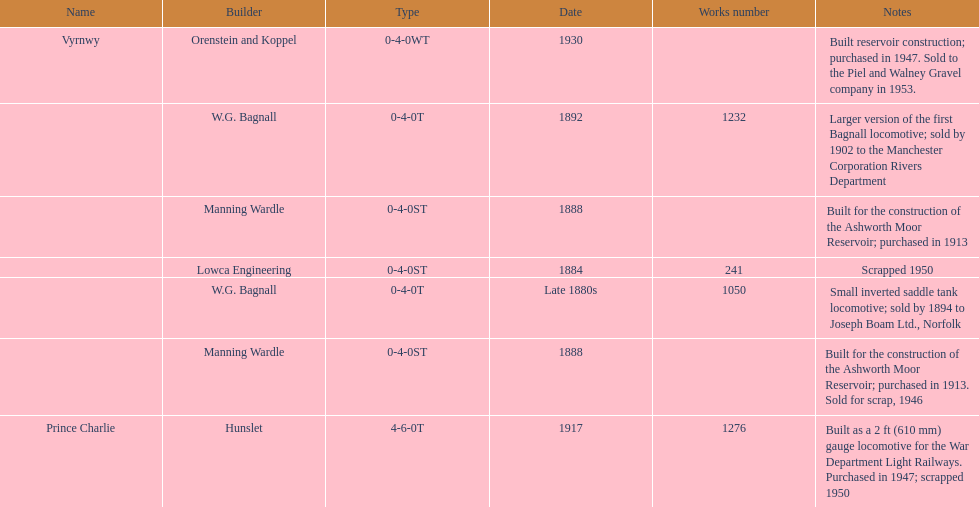Which locomotive builder built a locomotive after 1888 and built the locomotive as a 2ft gauge locomotive? Hunslet. 